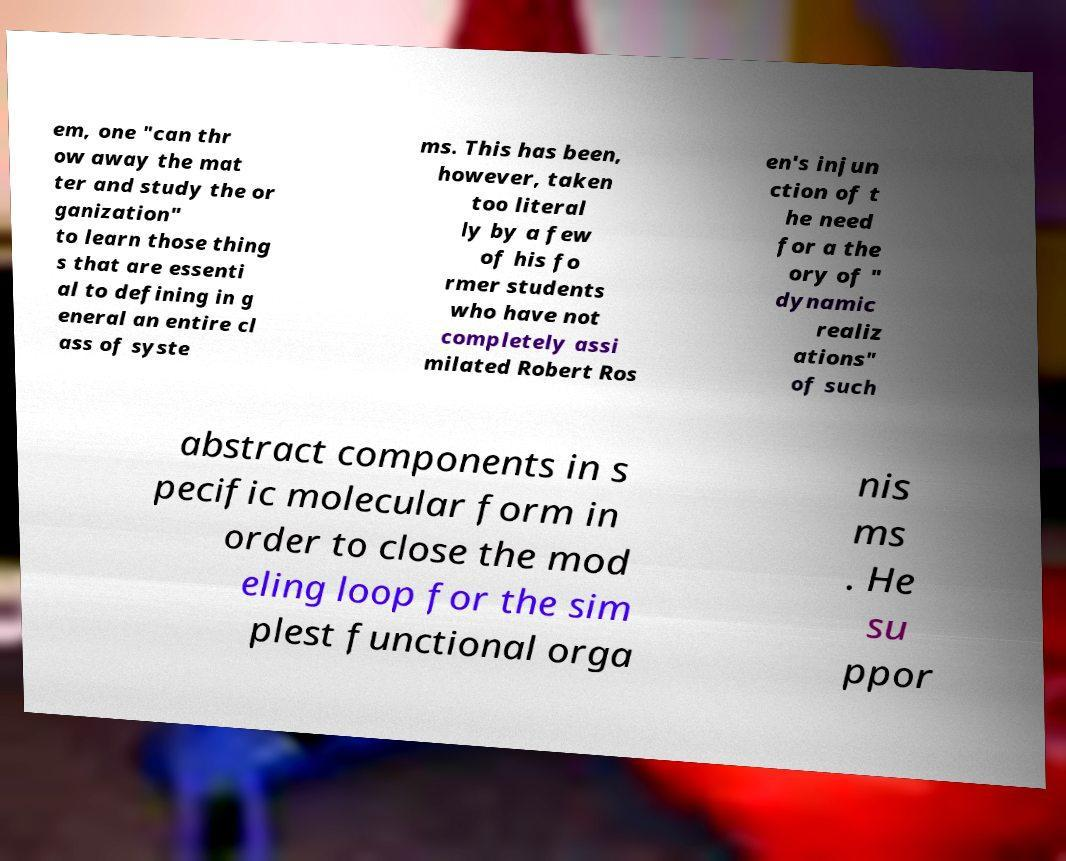There's text embedded in this image that I need extracted. Can you transcribe it verbatim? em, one "can thr ow away the mat ter and study the or ganization" to learn those thing s that are essenti al to defining in g eneral an entire cl ass of syste ms. This has been, however, taken too literal ly by a few of his fo rmer students who have not completely assi milated Robert Ros en's injun ction of t he need for a the ory of " dynamic realiz ations" of such abstract components in s pecific molecular form in order to close the mod eling loop for the sim plest functional orga nis ms . He su ppor 